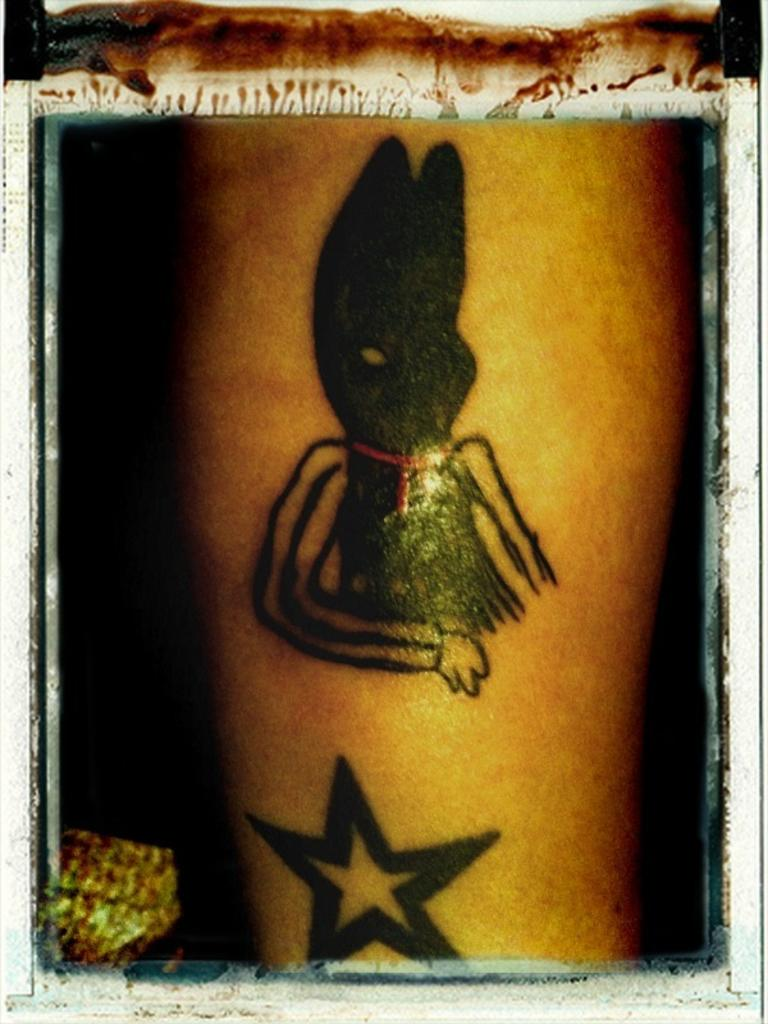What can be seen in the image? There is a person's hand in the image. Are there any distinguishing features on the hand? Yes, the hand has two tattoos. Can you tell if the image has been altered in any way? Yes, the image has borders, indicating that it has been edited. What type of drug is being stored in the drawer in the image? There is no drawer or drug present in the image; it only features a person's hand with tattoos. What scene is taking place in the image? The image only shows a person's hand with tattoos, so it is not possible to determine a specific scene. 